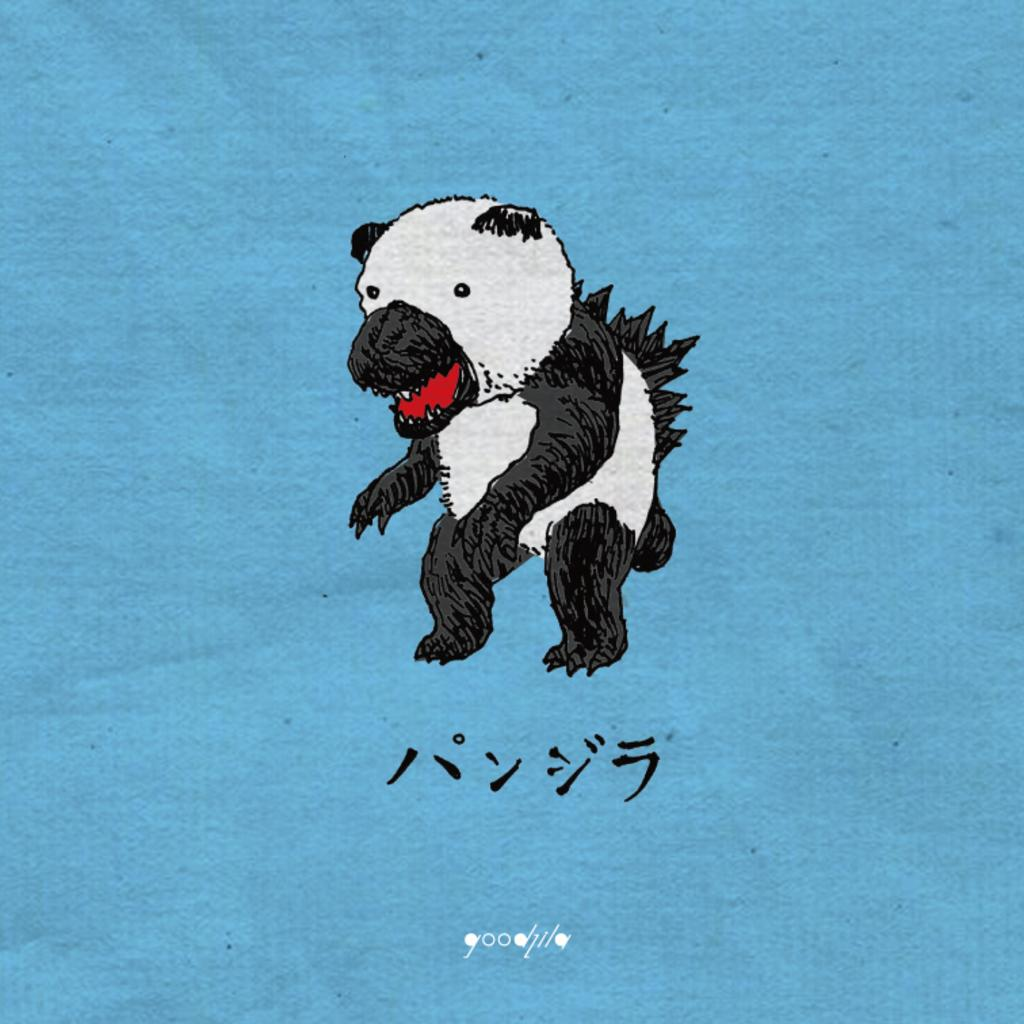What is the main subject of the image? There is a painting in the image. What is depicted in the painting? The painting depicts an animal. What color is the surface of the painting? The surface of the painting is blue. Can you see any rays of sunlight on the seashore in the image? There is no seashore or rays of sunlight present in the image; it features a painting with a blue surface and an animal depicted. 